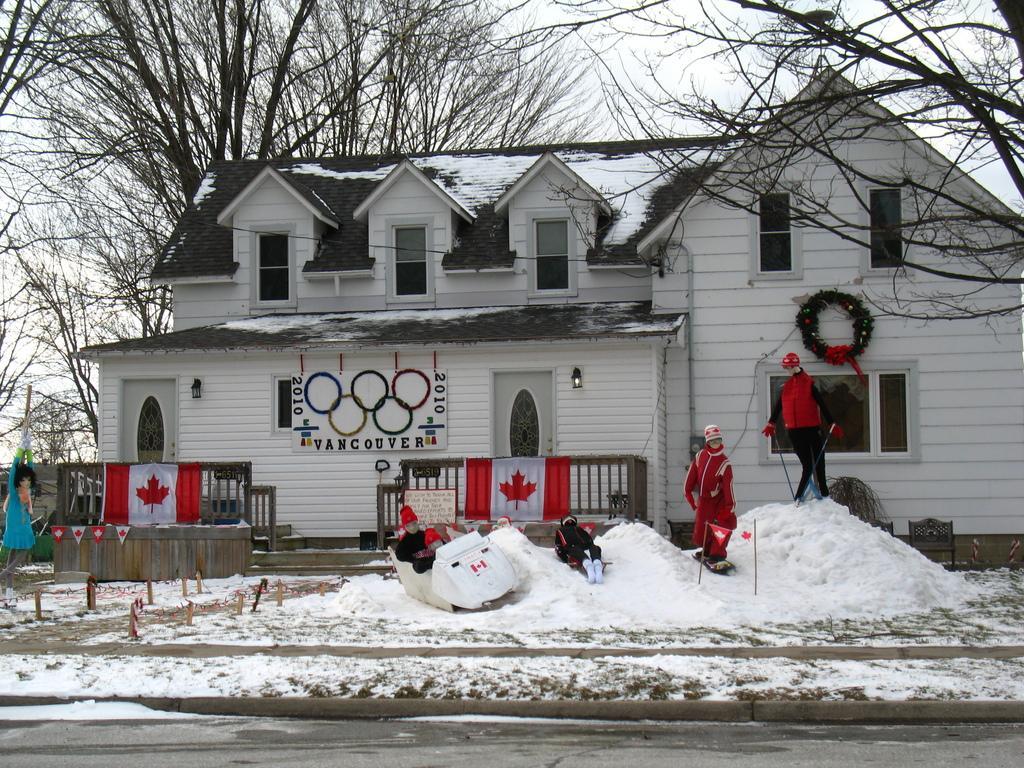Can you describe this image briefly? In this picture we can see snow and scarecrows, in the background we can see few trees, a house, flags and a hoarding. 